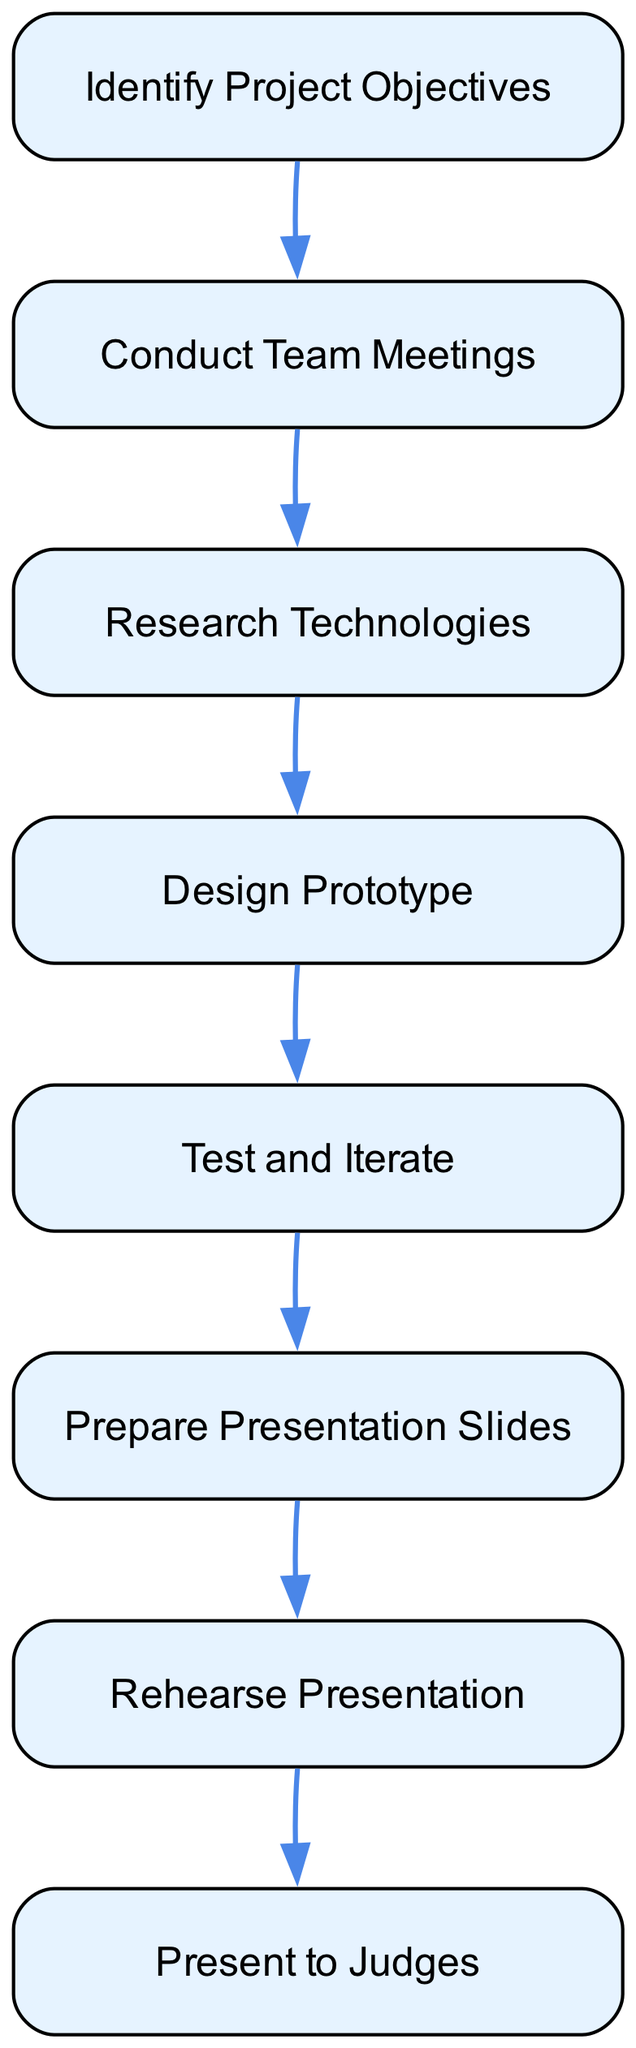What is the first step in the sequence? The first step in the sequence is represented by the node "Identify Project Objectives," which is the starting point of the process.
Answer: Identify Project Objectives How many total steps are there in the sequence? By counting the nodes in the diagram, there are eight distinct steps, each listed sequentially.
Answer: Eight Which step comes after "Design Prototype"? Following "Design Prototype," the next step in the sequence is "Test and Iterate," indicating the next action to be taken.
Answer: Test and Iterate What two steps are directly connected? The steps "Prepare Presentation Slides" and "Rehearse Presentation" are directly connected, as there is an edge connecting them, indicating the flow of the process.
Answer: Prepare Presentation Slides and Rehearse Presentation What happens before "Present to Judges"? The step immediately preceding "Present to Judges" is "Rehearse Presentation," indicating that practicing delivery is essential before the actual presentation.
Answer: Rehearse Presentation How does "Research Technologies" relate to the overall process? "Research Technologies" serves as foundational knowledge that informs subsequent steps such as "Design Prototype," reinforcing its importance in the sequence.
Answer: Informs the design process Which step ends the sequence? The sequence culminates in "Present to Judges," marking the conclusion of the robotics project development process for this specific sequence.
Answer: Present to Judges What is the connection between "Conduct Team Meetings" and "Test and Iterate"? "Conduct Team Meetings" leads to aligning team efforts, which is crucial for effective "Testing and Iterating" later in the sequence, showcasing a pathway of collaboration throughout the project.
Answer: Collaboration pathway What is the purpose of "Prepare Presentation Slides"? The purpose of "Prepare Presentation Slides" is to create visual aids that summarize the development process, essential for communicating progress and results effectively to the judges.
Answer: Create visual aids 